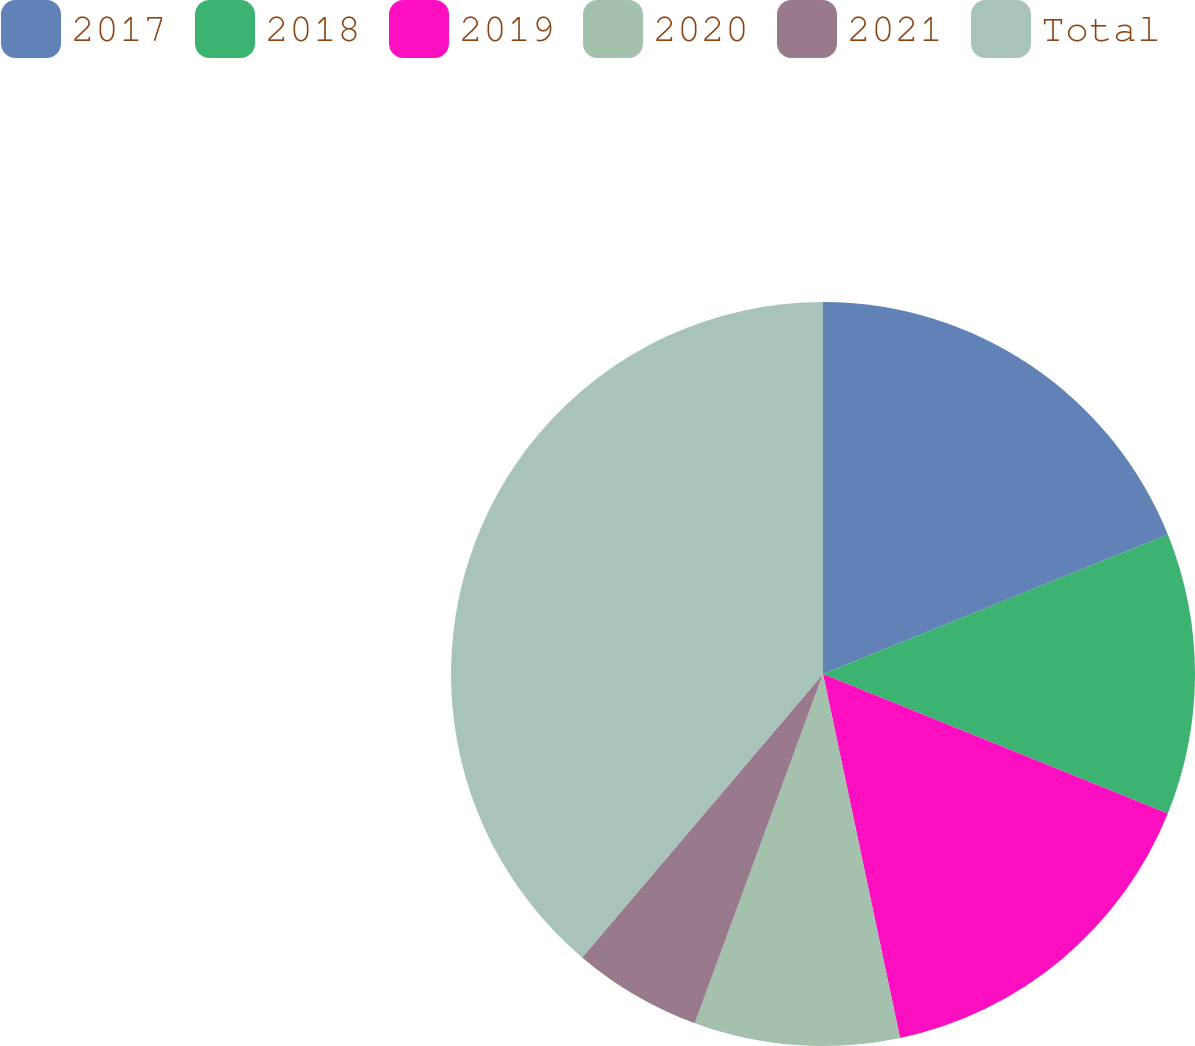Convert chart to OTSL. <chart><loc_0><loc_0><loc_500><loc_500><pie_chart><fcel>2017<fcel>2018<fcel>2019<fcel>2020<fcel>2021<fcel>Total<nl><fcel>18.88%<fcel>12.24%<fcel>15.56%<fcel>8.92%<fcel>5.61%<fcel>38.79%<nl></chart> 